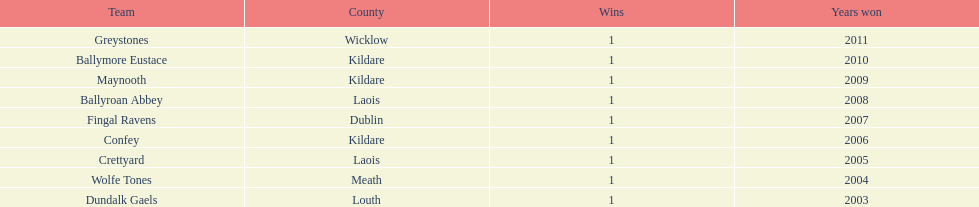Which team won after ballymore eustace? Greystones. Write the full table. {'header': ['Team', 'County', 'Wins', 'Years won'], 'rows': [['Greystones', 'Wicklow', '1', '2011'], ['Ballymore Eustace', 'Kildare', '1', '2010'], ['Maynooth', 'Kildare', '1', '2009'], ['Ballyroan Abbey', 'Laois', '1', '2008'], ['Fingal Ravens', 'Dublin', '1', '2007'], ['Confey', 'Kildare', '1', '2006'], ['Crettyard', 'Laois', '1', '2005'], ['Wolfe Tones', 'Meath', '1', '2004'], ['Dundalk Gaels', 'Louth', '1', '2003']]} 